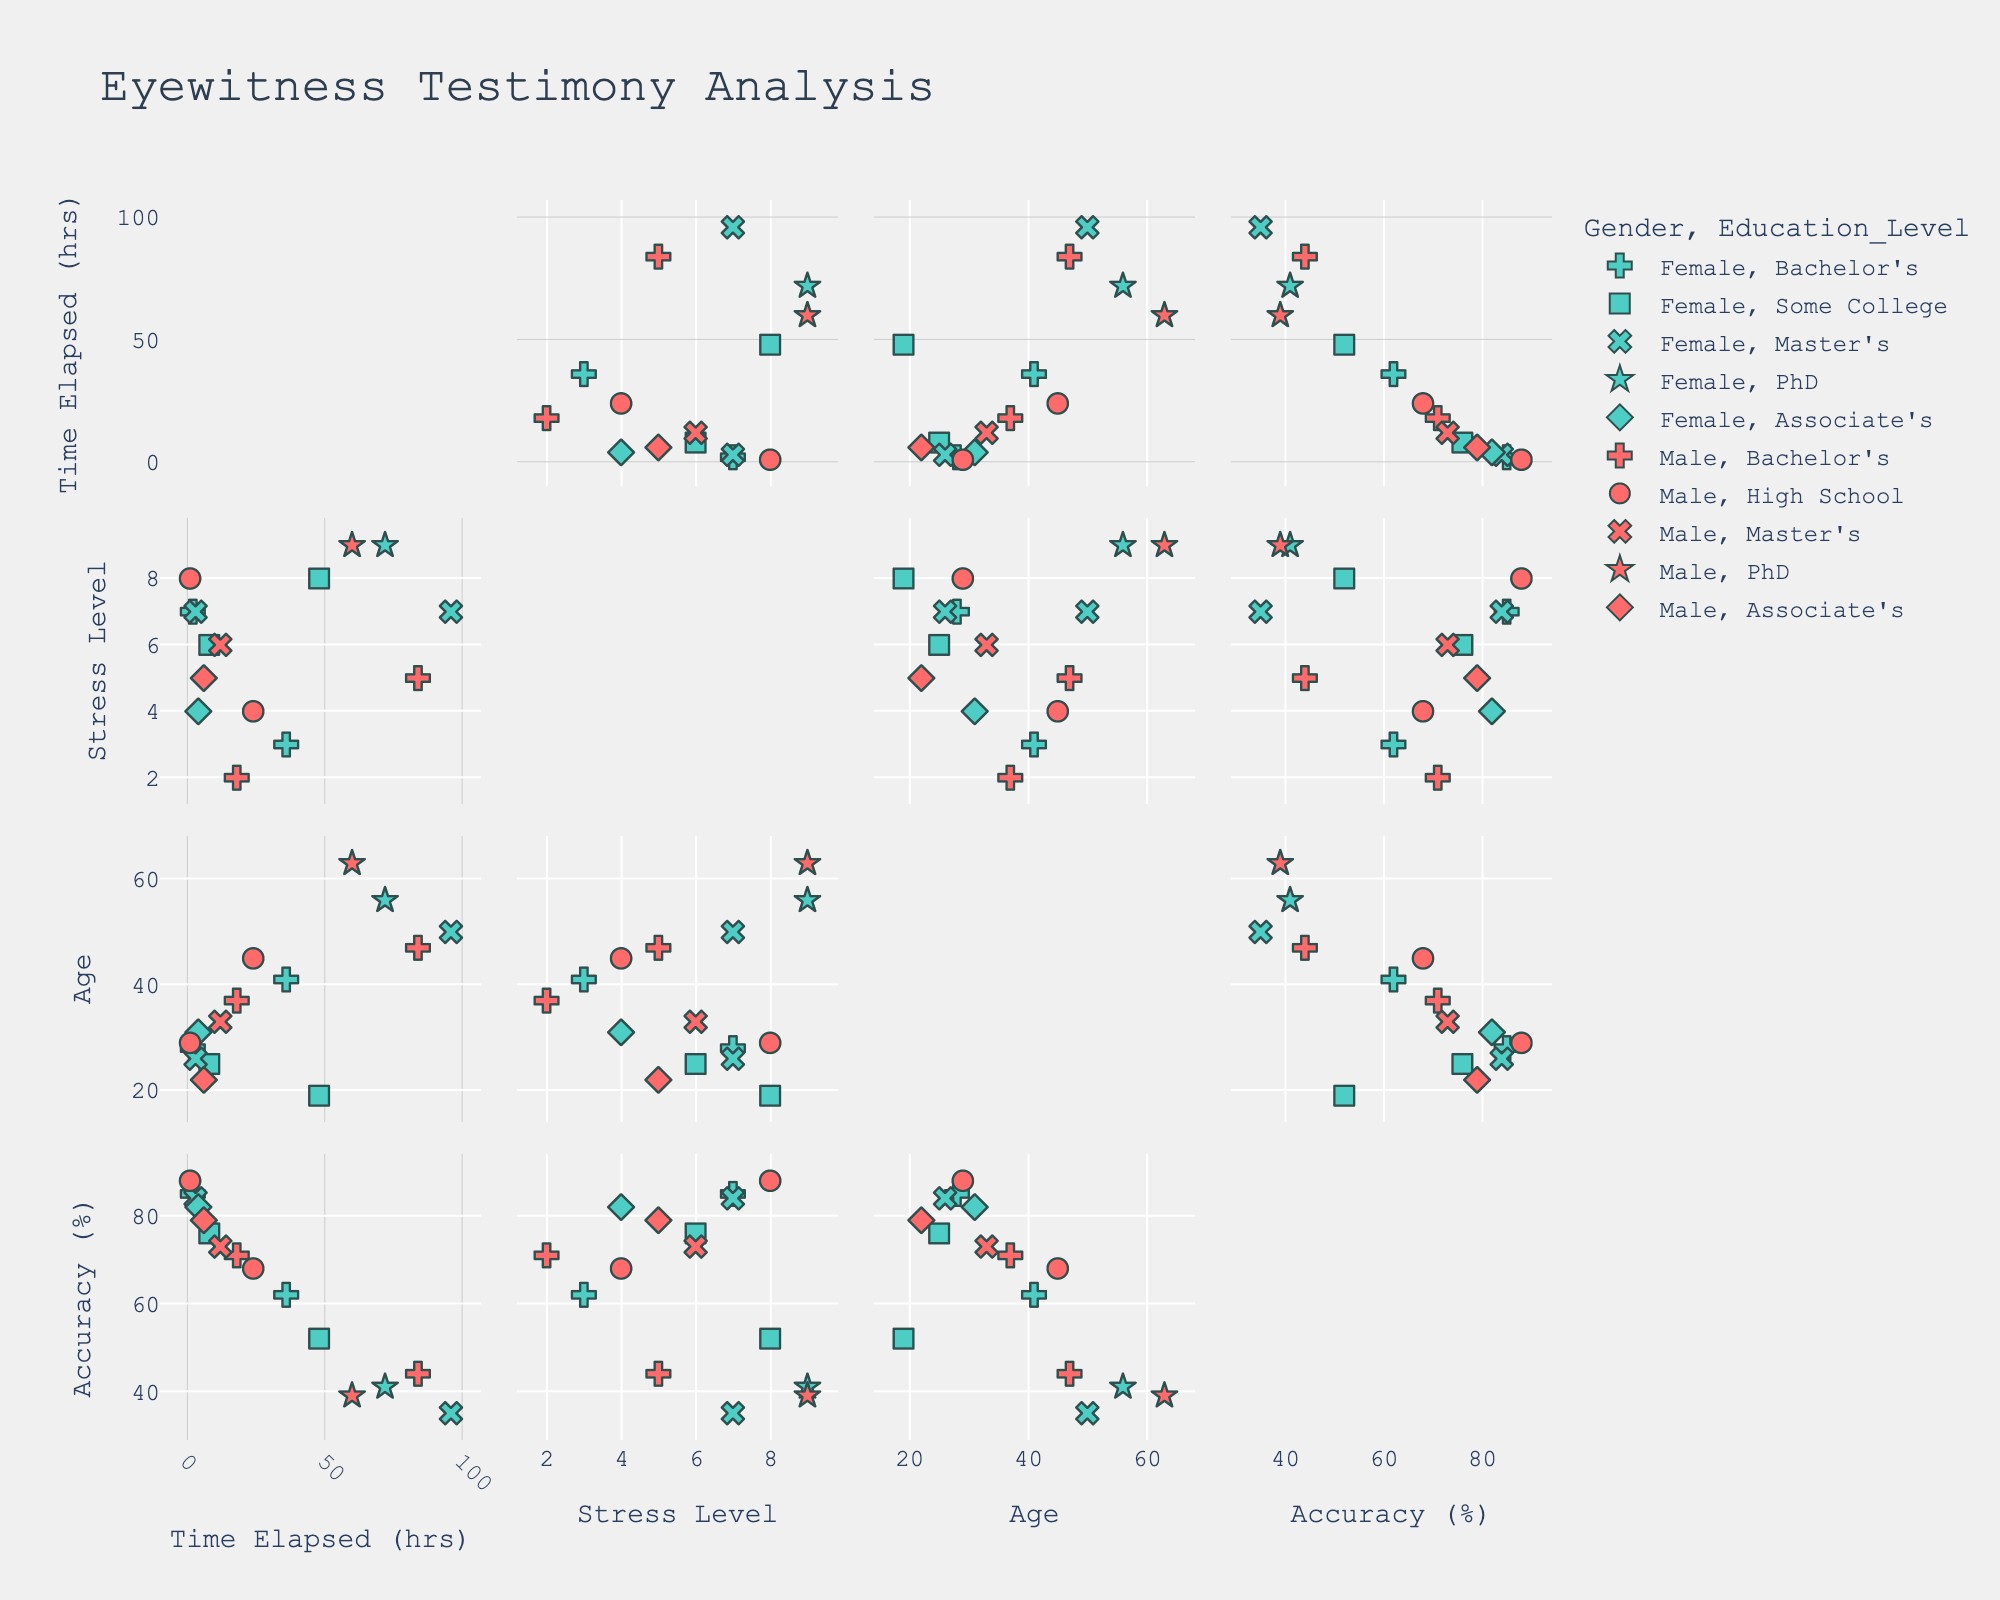How many data points are in the figure? The plot has points from different eyewitnesses. Since there are 15 unique entries in the provided dataset, we count each entry as a data point.
Answer: 15 What is the range of the ‘Time Elapsed (hrs)’ axis? Look at the minimum and maximum value ticks on the ‘Time Elapsed (hrs)’ axis. It ranges from 0 to approximately 100 hours.
Answer: 0 to 100 Which demographic shows the highest accuracy percentage, and what is its value? Identify the highest point on the 'Accuracy (%)' axis and check the corresponding demographic details (symbol and color). The highest accuracy (88%) is represented by a teal cross for a male with a high school education.
Answer: Male, 88% What is the relationship between stress levels and accuracy percentages? Observe the scatterplot matrix comparing Stress Level and Accuracy Percentage variables by looking for any visible pattern or trend. Higher stress levels seem to correspond with lower accuracy percentages.
Answer: Negative correlation Which gender has more eyewitnesses with a master’s degree in the dataset? Use the symbol 'x' to identify master’s degree holders and then count the occurrences of male (red color) and female (teal color). There are more females with a master’s degree (represented by teal x’s) than males.
Answer: Female What is the average accuracy percentage for witnesses with a PhD? Look for star symbols representing PhD holders, check the accuracy percentages of these points (41, 39), and compute the average: (41+39)/2 = 40.
Answer: 40 How do age and stress level vary between different genders? Compare the ‘Age’ and ‘Stress Level’ plots for points colored differently for males and females.
Answer: Males and females have a similar range in both age and stress level Is there any visible trend between Time Elapsed (hrs) and Accuracy Percentage? Examine the scatterplot comparing Time Elapsed (hrs) and Accuracy Percentage for any trend. Accuracy tends to decrease as the time elapsed increases.
Answer: Decreasing trend What is the median accuracy percentage for all eyewitnesses? Arrange all Accuracy Percentage values in ascending order and find the middle value. (35, 39, 41, 44, 52, 62, 68, 71, 73, 76, 79, 82, 84, 85, 88). The median is the eighth value, which is 71.
Answer: 71 Compare the average stress level of witnesses under 30 and those over 30. Separate the ages into two groups: under 30 (7, 8, 6, 5, 8, 6, 4, 7) and over 30 (4, 9, 3, 2, 7, 9, 5, 5). Calculate the averages: under 30 (6.375) and over 30 (5.5). Under 30 has a higher average stress level.
Answer: Higher for under 30 